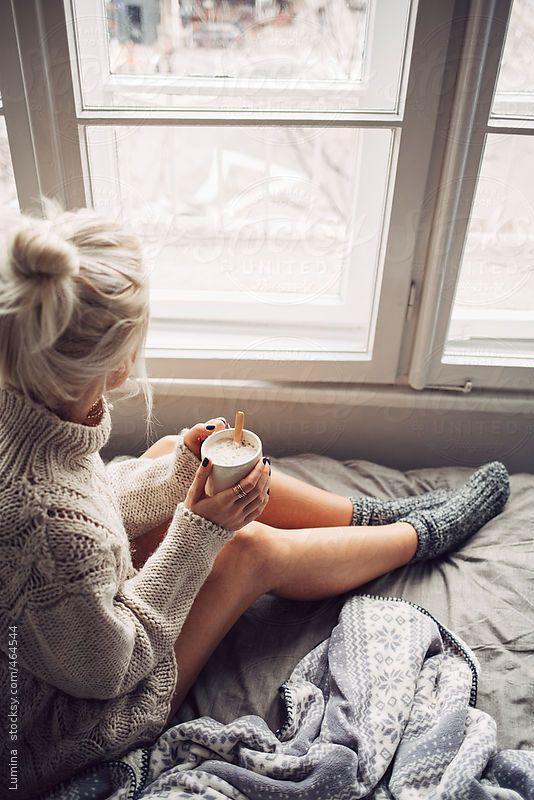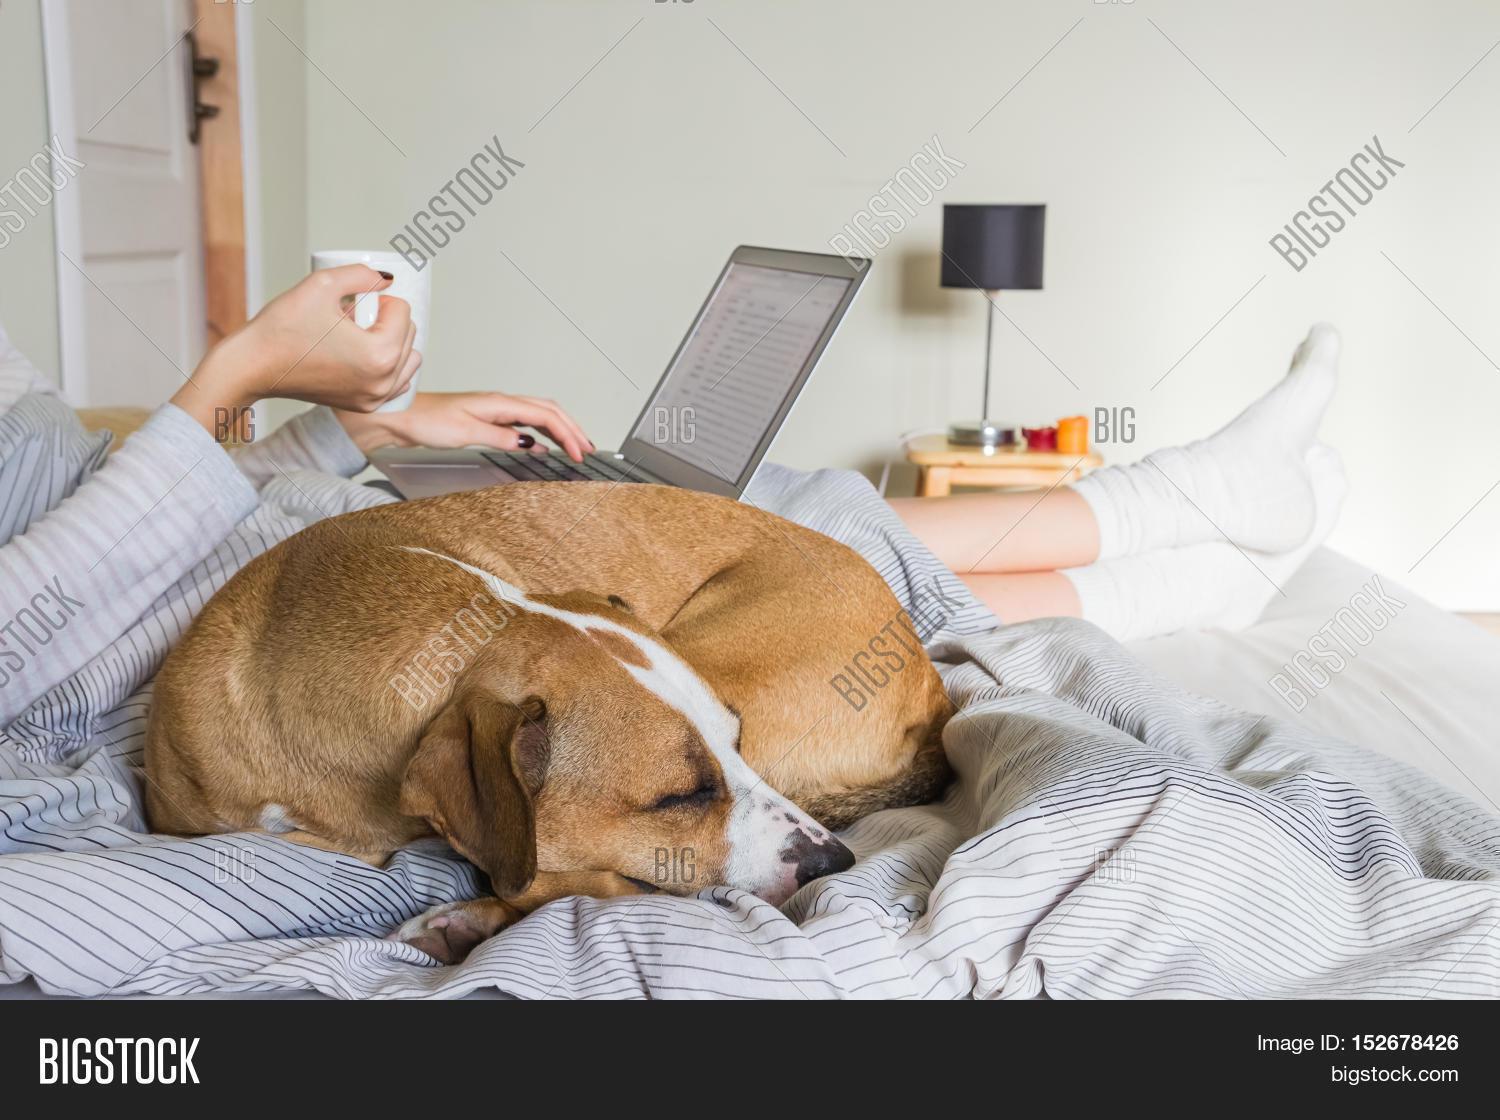The first image is the image on the left, the second image is the image on the right. For the images displayed, is the sentence "In one image a woman is sitting on a bed with her legs crossed and holding a beverage in a white cup." factually correct? Answer yes or no. No. The first image is the image on the left, the second image is the image on the right. Considering the images on both sides, is "The left image contains a human sitting on a bed holding a coffee cup." valid? Answer yes or no. Yes. 